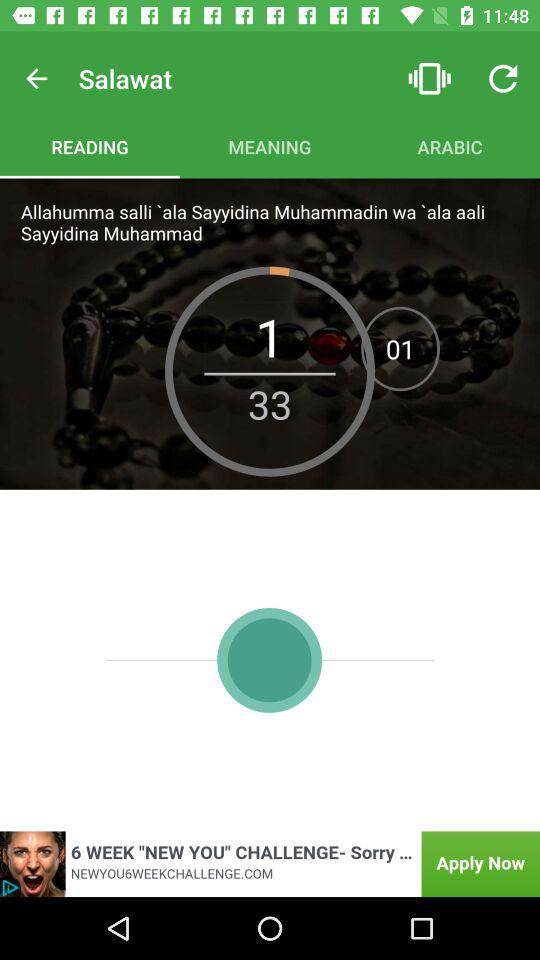What is the total number of downloads? The total number of downloads is 33. 